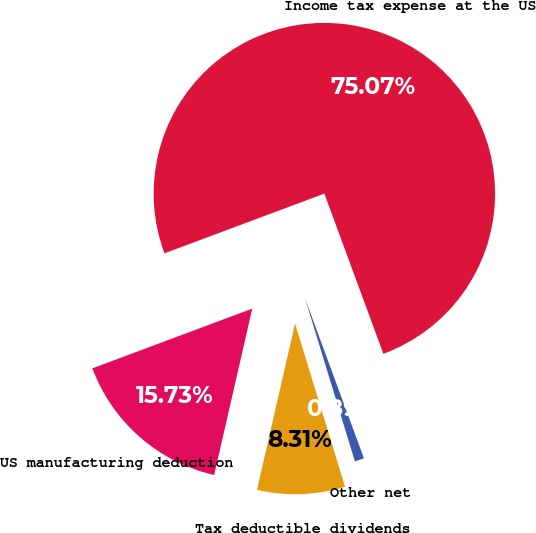Convert chart to OTSL. <chart><loc_0><loc_0><loc_500><loc_500><pie_chart><fcel>Income tax expense at the US<fcel>US manufacturing deduction<fcel>Tax deductible dividends<fcel>Other net<nl><fcel>75.08%<fcel>15.73%<fcel>8.31%<fcel>0.89%<nl></chart> 